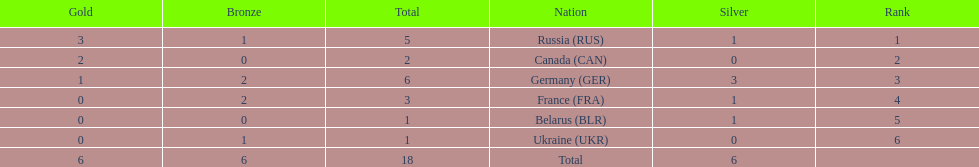Who had a larger total medal count, france or canada? France. 